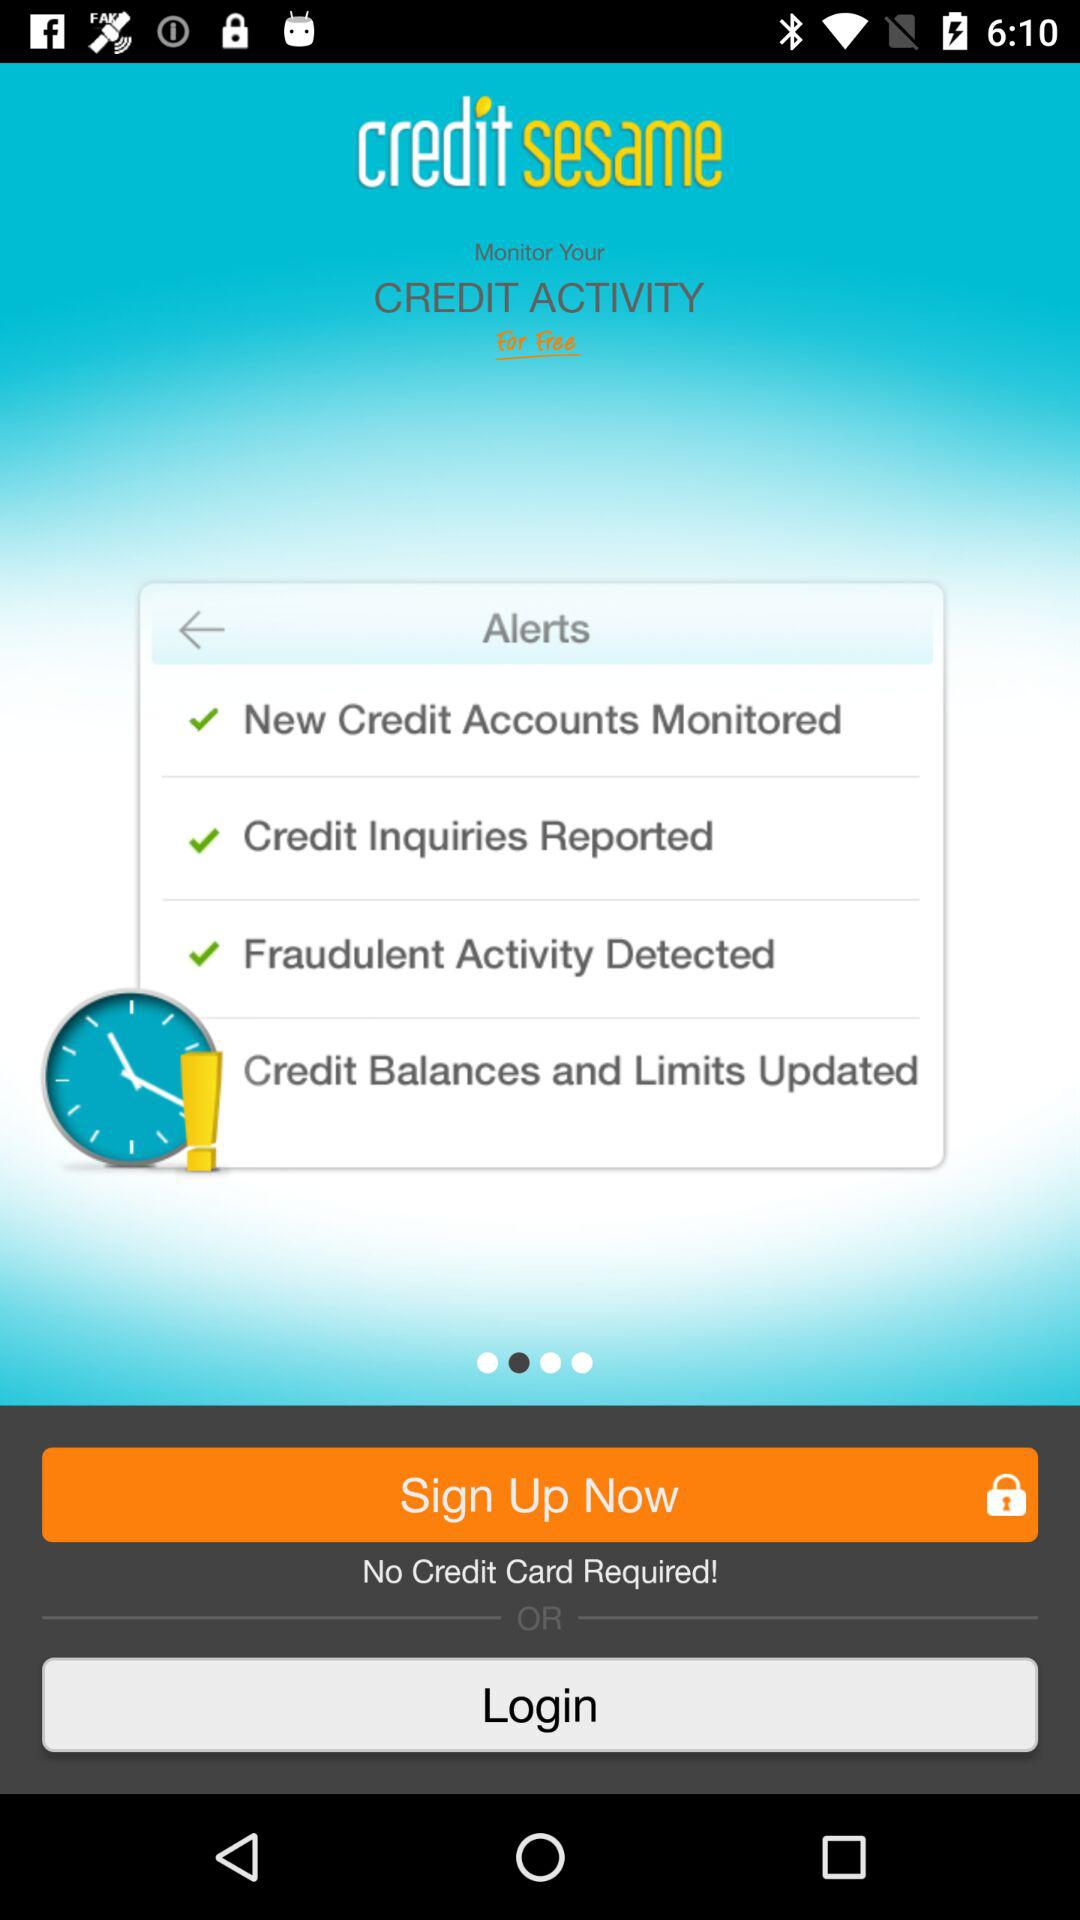What is the name of the application? The name of the application is "credit sesame". 